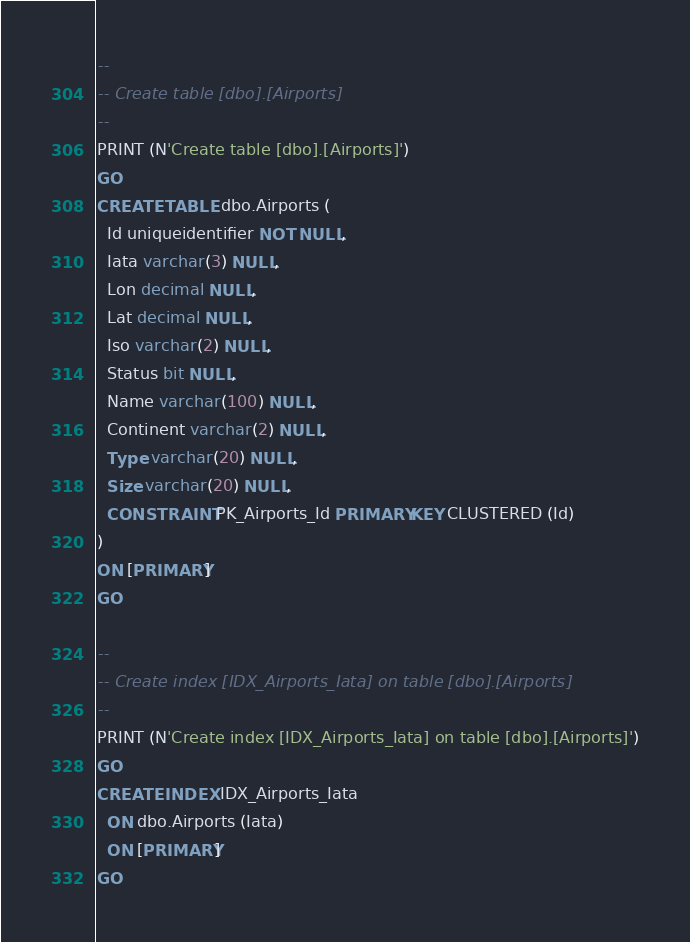<code> <loc_0><loc_0><loc_500><loc_500><_SQL_>--
-- Create table [dbo].[Airports]
--
PRINT (N'Create table [dbo].[Airports]')
GO
CREATE TABLE dbo.Airports (
  Id uniqueidentifier NOT NULL,
  Iata varchar(3) NULL,
  Lon decimal NULL,
  Lat decimal NULL,
  Iso varchar(2) NULL,
  Status bit NULL,
  Name varchar(100) NULL,
  Continent varchar(2) NULL,
  Type varchar(20) NULL,
  Size varchar(20) NULL,
  CONSTRAINT PK_Airports_Id PRIMARY KEY CLUSTERED (Id)
)
ON [PRIMARY]
GO

--
-- Create index [IDX_Airports_Iata] on table [dbo].[Airports]
--
PRINT (N'Create index [IDX_Airports_Iata] on table [dbo].[Airports]')
GO
CREATE INDEX IDX_Airports_Iata
  ON dbo.Airports (Iata)
  ON [PRIMARY]
GO</code> 